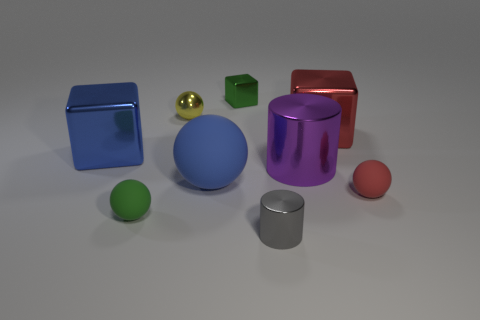There is a rubber sphere that is the same color as the small cube; what is its size?
Provide a succinct answer. Small. What material is the small sphere that is the same color as the small metal block?
Ensure brevity in your answer.  Rubber. There is a blue matte thing; does it have the same size as the green thing that is in front of the large red metallic thing?
Make the answer very short. No. What color is the rubber thing right of the small shiny cube behind the big blue block?
Provide a short and direct response. Red. What number of objects are either blocks that are on the left side of the tiny gray cylinder or green shiny blocks that are left of the large purple metallic thing?
Keep it short and to the point. 2. Is the size of the yellow ball the same as the red metallic thing?
Provide a short and direct response. No. Is the shape of the large red thing behind the large rubber ball the same as the tiny green object that is behind the red cube?
Provide a succinct answer. Yes. What size is the blue matte ball?
Give a very brief answer. Large. What is the material of the green thing in front of the block that is in front of the big metallic block that is right of the tiny yellow thing?
Ensure brevity in your answer.  Rubber. How many other things are the same color as the tiny cube?
Ensure brevity in your answer.  1. 